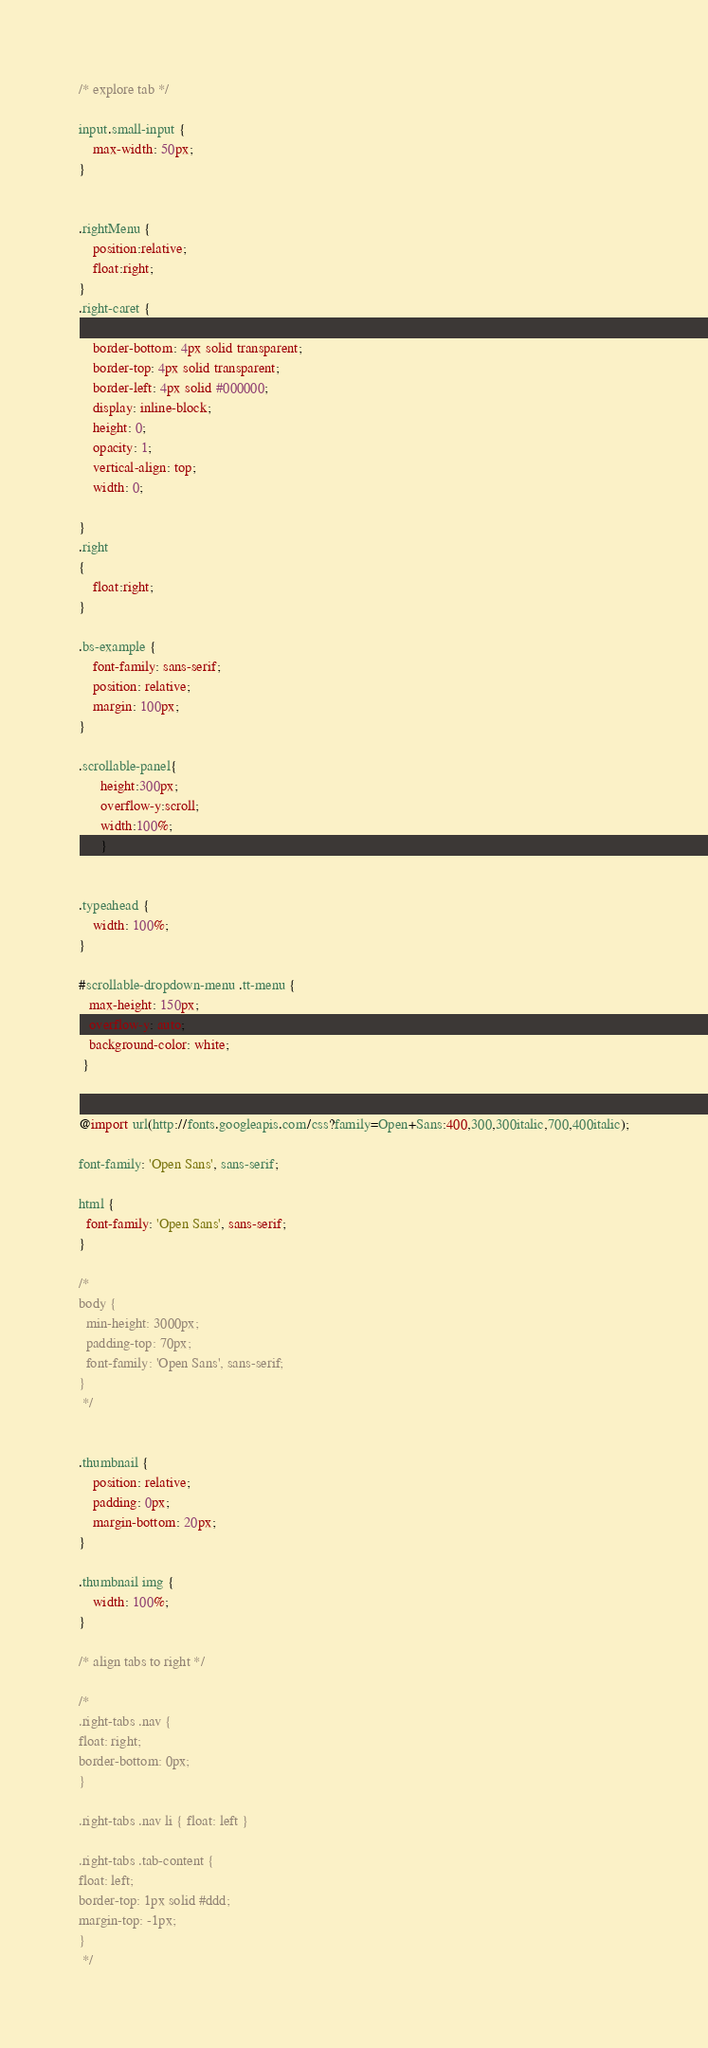Convert code to text. <code><loc_0><loc_0><loc_500><loc_500><_CSS_>
/* explore tab */

input.small-input {
	max-width: 50px;
}


.rightMenu {
    position:relative;
    float:right;
}
.right-caret {

    border-bottom: 4px solid transparent;
    border-top: 4px solid transparent;
    border-left: 4px solid #000000;
    display: inline-block;
    height: 0;
    opacity: 1;
    vertical-align: top;
    width: 0;

}
.right
{
    float:right;
}

.bs-example {
	font-family: sans-serif;
	position: relative;
	margin: 100px;
}

.scrollable-panel{
      height:300px;
      overflow-y:scroll;
      width:100%;
      }


.typeahead {
	width: 100%;
}

#scrollable-dropdown-menu .tt-menu {
   max-height: 150px;
   overflow-y: auto;
   background-color: white;
 }


@import url(http://fonts.googleapis.com/css?family=Open+Sans:400,300,300italic,700,400italic);

font-family: 'Open Sans', sans-serif;

html {
  font-family: 'Open Sans', sans-serif;
}

/*
body {
  min-height: 3000px;
  padding-top: 70px;
  font-family: 'Open Sans', sans-serif;
}
 */


.thumbnail {
    position: relative;
    padding: 0px;
    margin-bottom: 20px;
}

.thumbnail img {
    width: 100%;
}

/* align tabs to right */

/*
.right-tabs .nav {
float: right;
border-bottom: 0px;
}

.right-tabs .nav li { float: left }

.right-tabs .tab-content {
float: left;
border-top: 1px solid #ddd;
margin-top: -1px;
}
 */

</code> 